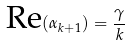<formula> <loc_0><loc_0><loc_500><loc_500>\text {Re} ( \alpha _ { k + 1 } ) = \frac { \gamma } { k }</formula> 